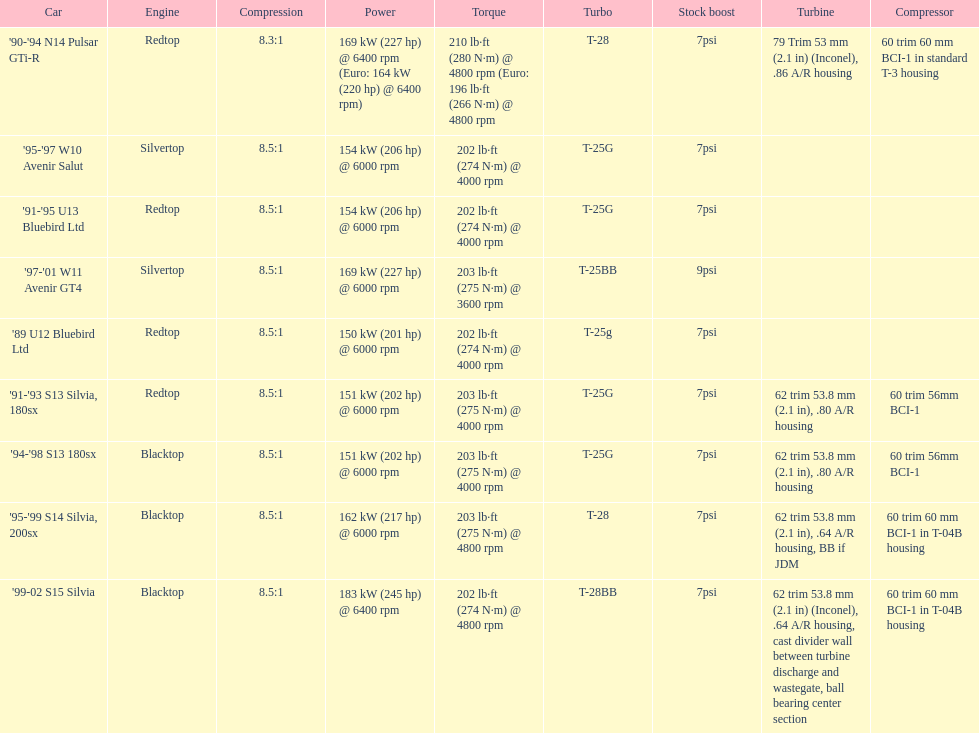Would you be able to parse every entry in this table? {'header': ['Car', 'Engine', 'Compression', 'Power', 'Torque', 'Turbo', 'Stock boost', 'Turbine', 'Compressor'], 'rows': [["'90-'94 N14 Pulsar GTi-R", 'Redtop', '8.3:1', '169\xa0kW (227\xa0hp) @ 6400 rpm (Euro: 164\xa0kW (220\xa0hp) @ 6400 rpm)', '210\xa0lb·ft (280\xa0N·m) @ 4800 rpm (Euro: 196\xa0lb·ft (266\xa0N·m) @ 4800 rpm', 'T-28', '7psi', '79 Trim 53\xa0mm (2.1\xa0in) (Inconel), .86 A/R housing', '60 trim 60\xa0mm BCI-1 in standard T-3 housing'], ["'95-'97 W10 Avenir Salut", 'Silvertop', '8.5:1', '154\xa0kW (206\xa0hp) @ 6000 rpm', '202\xa0lb·ft (274\xa0N·m) @ 4000 rpm', 'T-25G', '7psi', '', ''], ["'91-'95 U13 Bluebird Ltd", 'Redtop', '8.5:1', '154\xa0kW (206\xa0hp) @ 6000 rpm', '202\xa0lb·ft (274\xa0N·m) @ 4000 rpm', 'T-25G', '7psi', '', ''], ["'97-'01 W11 Avenir GT4", 'Silvertop', '8.5:1', '169\xa0kW (227\xa0hp) @ 6000 rpm', '203\xa0lb·ft (275\xa0N·m) @ 3600 rpm', 'T-25BB', '9psi', '', ''], ["'89 U12 Bluebird Ltd", 'Redtop', '8.5:1', '150\xa0kW (201\xa0hp) @ 6000 rpm', '202\xa0lb·ft (274\xa0N·m) @ 4000 rpm', 'T-25g', '7psi', '', ''], ["'91-'93 S13 Silvia, 180sx", 'Redtop', '8.5:1', '151\xa0kW (202\xa0hp) @ 6000 rpm', '203\xa0lb·ft (275\xa0N·m) @ 4000 rpm', 'T-25G', '7psi', '62 trim 53.8\xa0mm (2.1\xa0in), .80 A/R housing', '60 trim 56mm BCI-1'], ["'94-'98 S13 180sx", 'Blacktop', '8.5:1', '151\xa0kW (202\xa0hp) @ 6000 rpm', '203\xa0lb·ft (275\xa0N·m) @ 4000 rpm', 'T-25G', '7psi', '62 trim 53.8\xa0mm (2.1\xa0in), .80 A/R housing', '60 trim 56mm BCI-1'], ["'95-'99 S14 Silvia, 200sx", 'Blacktop', '8.5:1', '162\xa0kW (217\xa0hp) @ 6000 rpm', '203\xa0lb·ft (275\xa0N·m) @ 4800 rpm', 'T-28', '7psi', '62 trim 53.8\xa0mm (2.1\xa0in), .64 A/R housing, BB if JDM', '60 trim 60\xa0mm BCI-1 in T-04B housing'], ["'99-02 S15 Silvia", 'Blacktop', '8.5:1', '183\xa0kW (245\xa0hp) @ 6400 rpm', '202\xa0lb·ft (274\xa0N·m) @ 4800 rpm', 'T-28BB', '7psi', '62 trim 53.8\xa0mm (2.1\xa0in) (Inconel), .64 A/R housing, cast divider wall between turbine discharge and wastegate, ball bearing center section', '60 trim 60\xa0mm BCI-1 in T-04B housing']]} Which car is the only one with more than 230 hp? '99-02 S15 Silvia. 